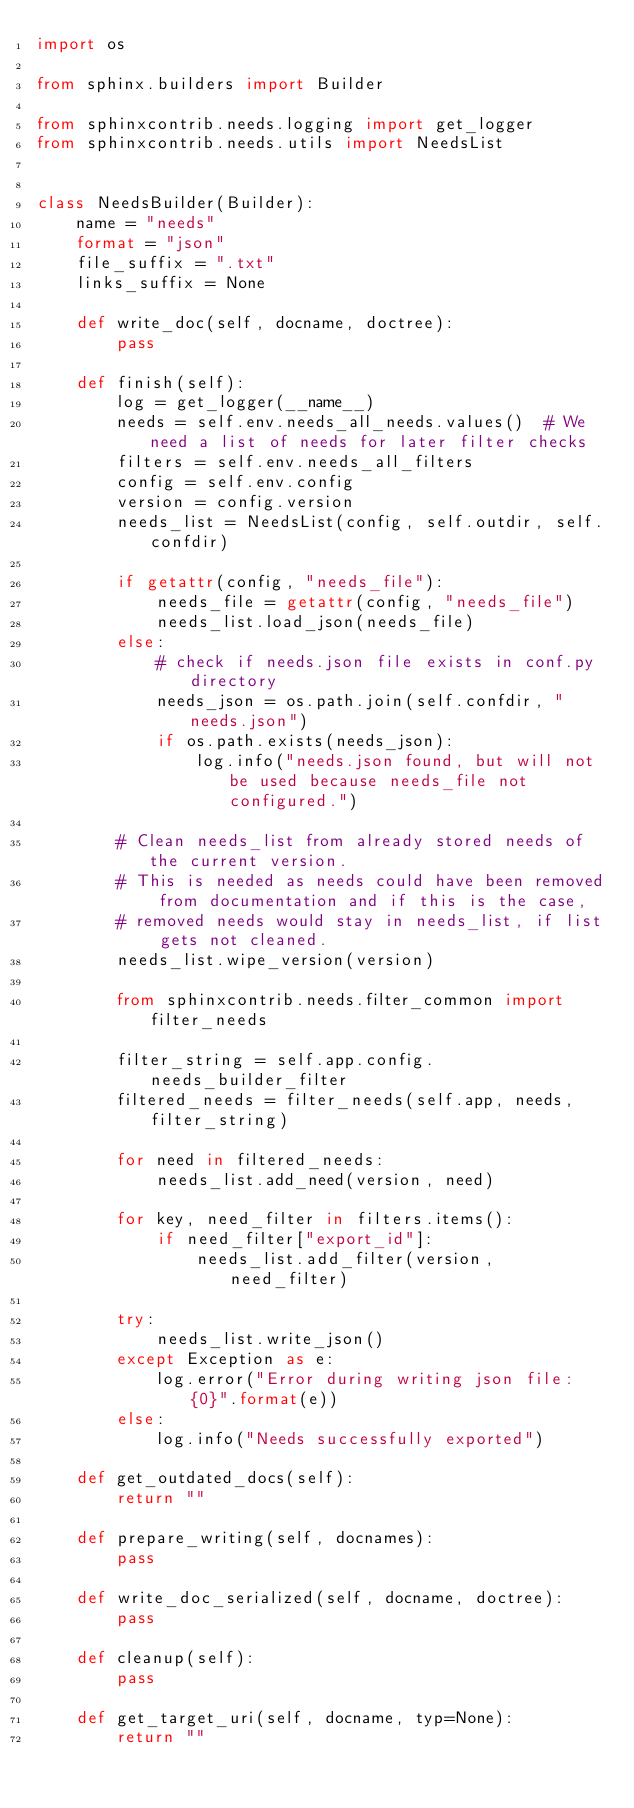<code> <loc_0><loc_0><loc_500><loc_500><_Python_>import os

from sphinx.builders import Builder

from sphinxcontrib.needs.logging import get_logger
from sphinxcontrib.needs.utils import NeedsList


class NeedsBuilder(Builder):
    name = "needs"
    format = "json"
    file_suffix = ".txt"
    links_suffix = None

    def write_doc(self, docname, doctree):
        pass

    def finish(self):
        log = get_logger(__name__)
        needs = self.env.needs_all_needs.values()  # We need a list of needs for later filter checks
        filters = self.env.needs_all_filters
        config = self.env.config
        version = config.version
        needs_list = NeedsList(config, self.outdir, self.confdir)

        if getattr(config, "needs_file"):
            needs_file = getattr(config, "needs_file")
            needs_list.load_json(needs_file)
        else:
            # check if needs.json file exists in conf.py directory
            needs_json = os.path.join(self.confdir, "needs.json")
            if os.path.exists(needs_json):
                log.info("needs.json found, but will not be used because needs_file not configured.")

        # Clean needs_list from already stored needs of the current version.
        # This is needed as needs could have been removed from documentation and if this is the case,
        # removed needs would stay in needs_list, if list gets not cleaned.
        needs_list.wipe_version(version)

        from sphinxcontrib.needs.filter_common import filter_needs

        filter_string = self.app.config.needs_builder_filter
        filtered_needs = filter_needs(self.app, needs, filter_string)

        for need in filtered_needs:
            needs_list.add_need(version, need)

        for key, need_filter in filters.items():
            if need_filter["export_id"]:
                needs_list.add_filter(version, need_filter)

        try:
            needs_list.write_json()
        except Exception as e:
            log.error("Error during writing json file: {0}".format(e))
        else:
            log.info("Needs successfully exported")

    def get_outdated_docs(self):
        return ""

    def prepare_writing(self, docnames):
        pass

    def write_doc_serialized(self, docname, doctree):
        pass

    def cleanup(self):
        pass

    def get_target_uri(self, docname, typ=None):
        return ""
</code> 